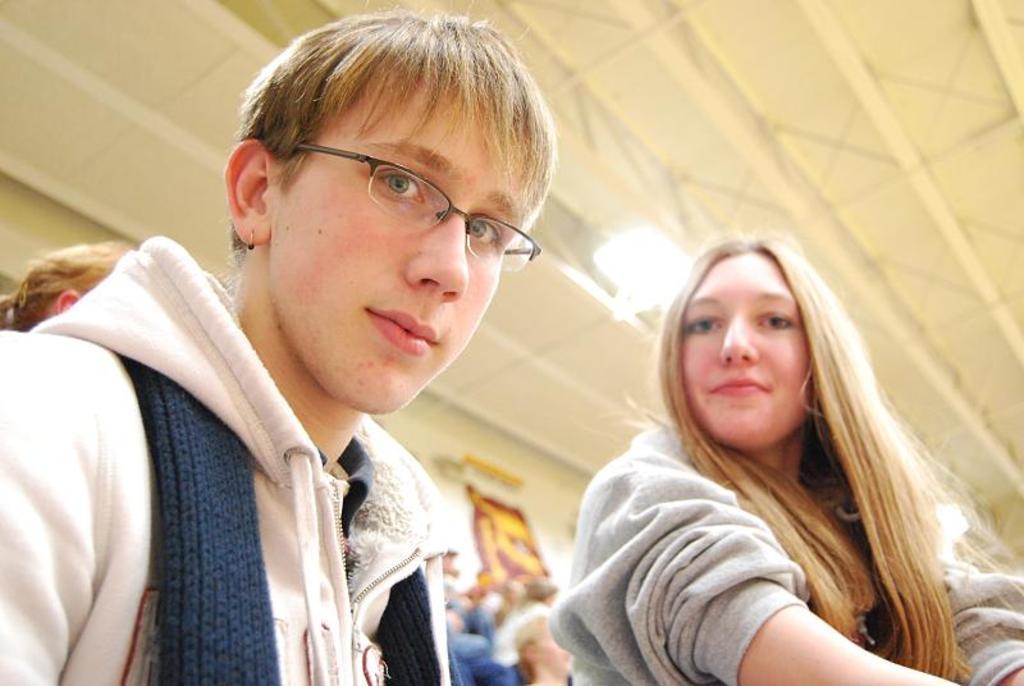Describe this image in one or two sentences. In this image there are people. In the background there is a poster and we can see a light. 